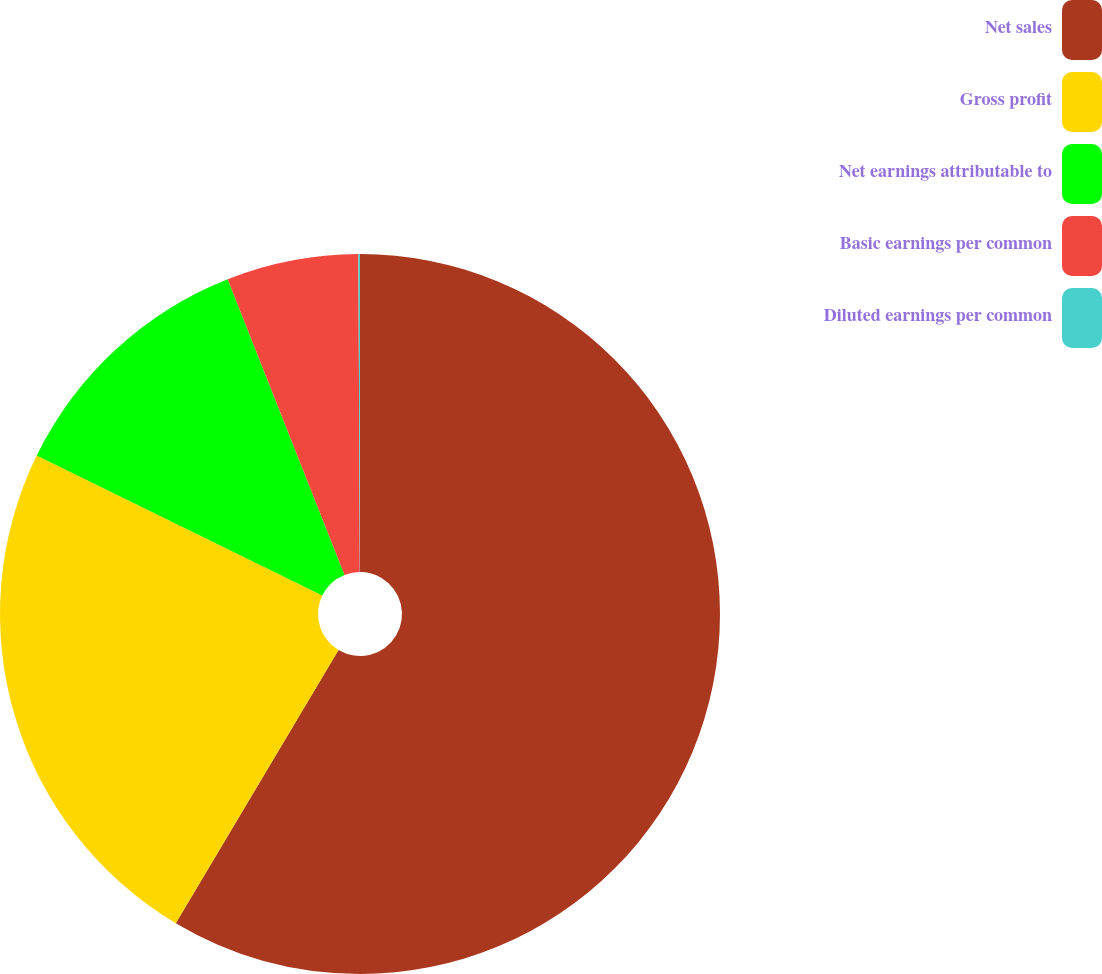<chart> <loc_0><loc_0><loc_500><loc_500><pie_chart><fcel>Net sales<fcel>Gross profit<fcel>Net earnings attributable to<fcel>Basic earnings per common<fcel>Diluted earnings per common<nl><fcel>58.55%<fcel>23.7%<fcel>11.76%<fcel>5.92%<fcel>0.07%<nl></chart> 